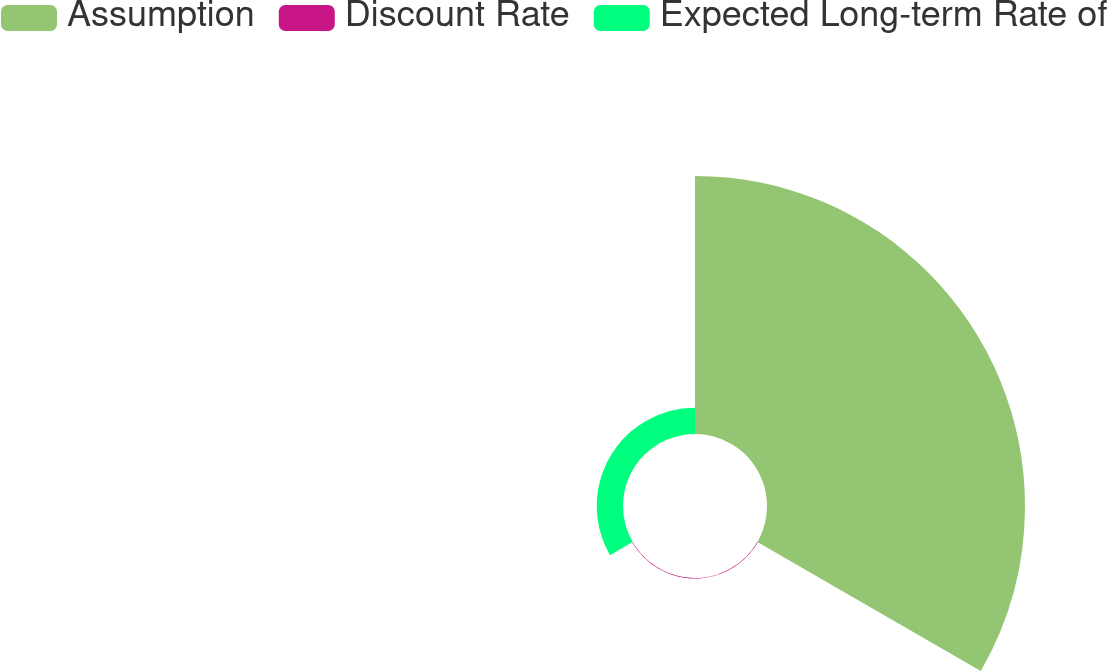<chart> <loc_0><loc_0><loc_500><loc_500><pie_chart><fcel>Assumption<fcel>Discount Rate<fcel>Expected Long-term Rate of<nl><fcel>90.57%<fcel>0.2%<fcel>9.23%<nl></chart> 